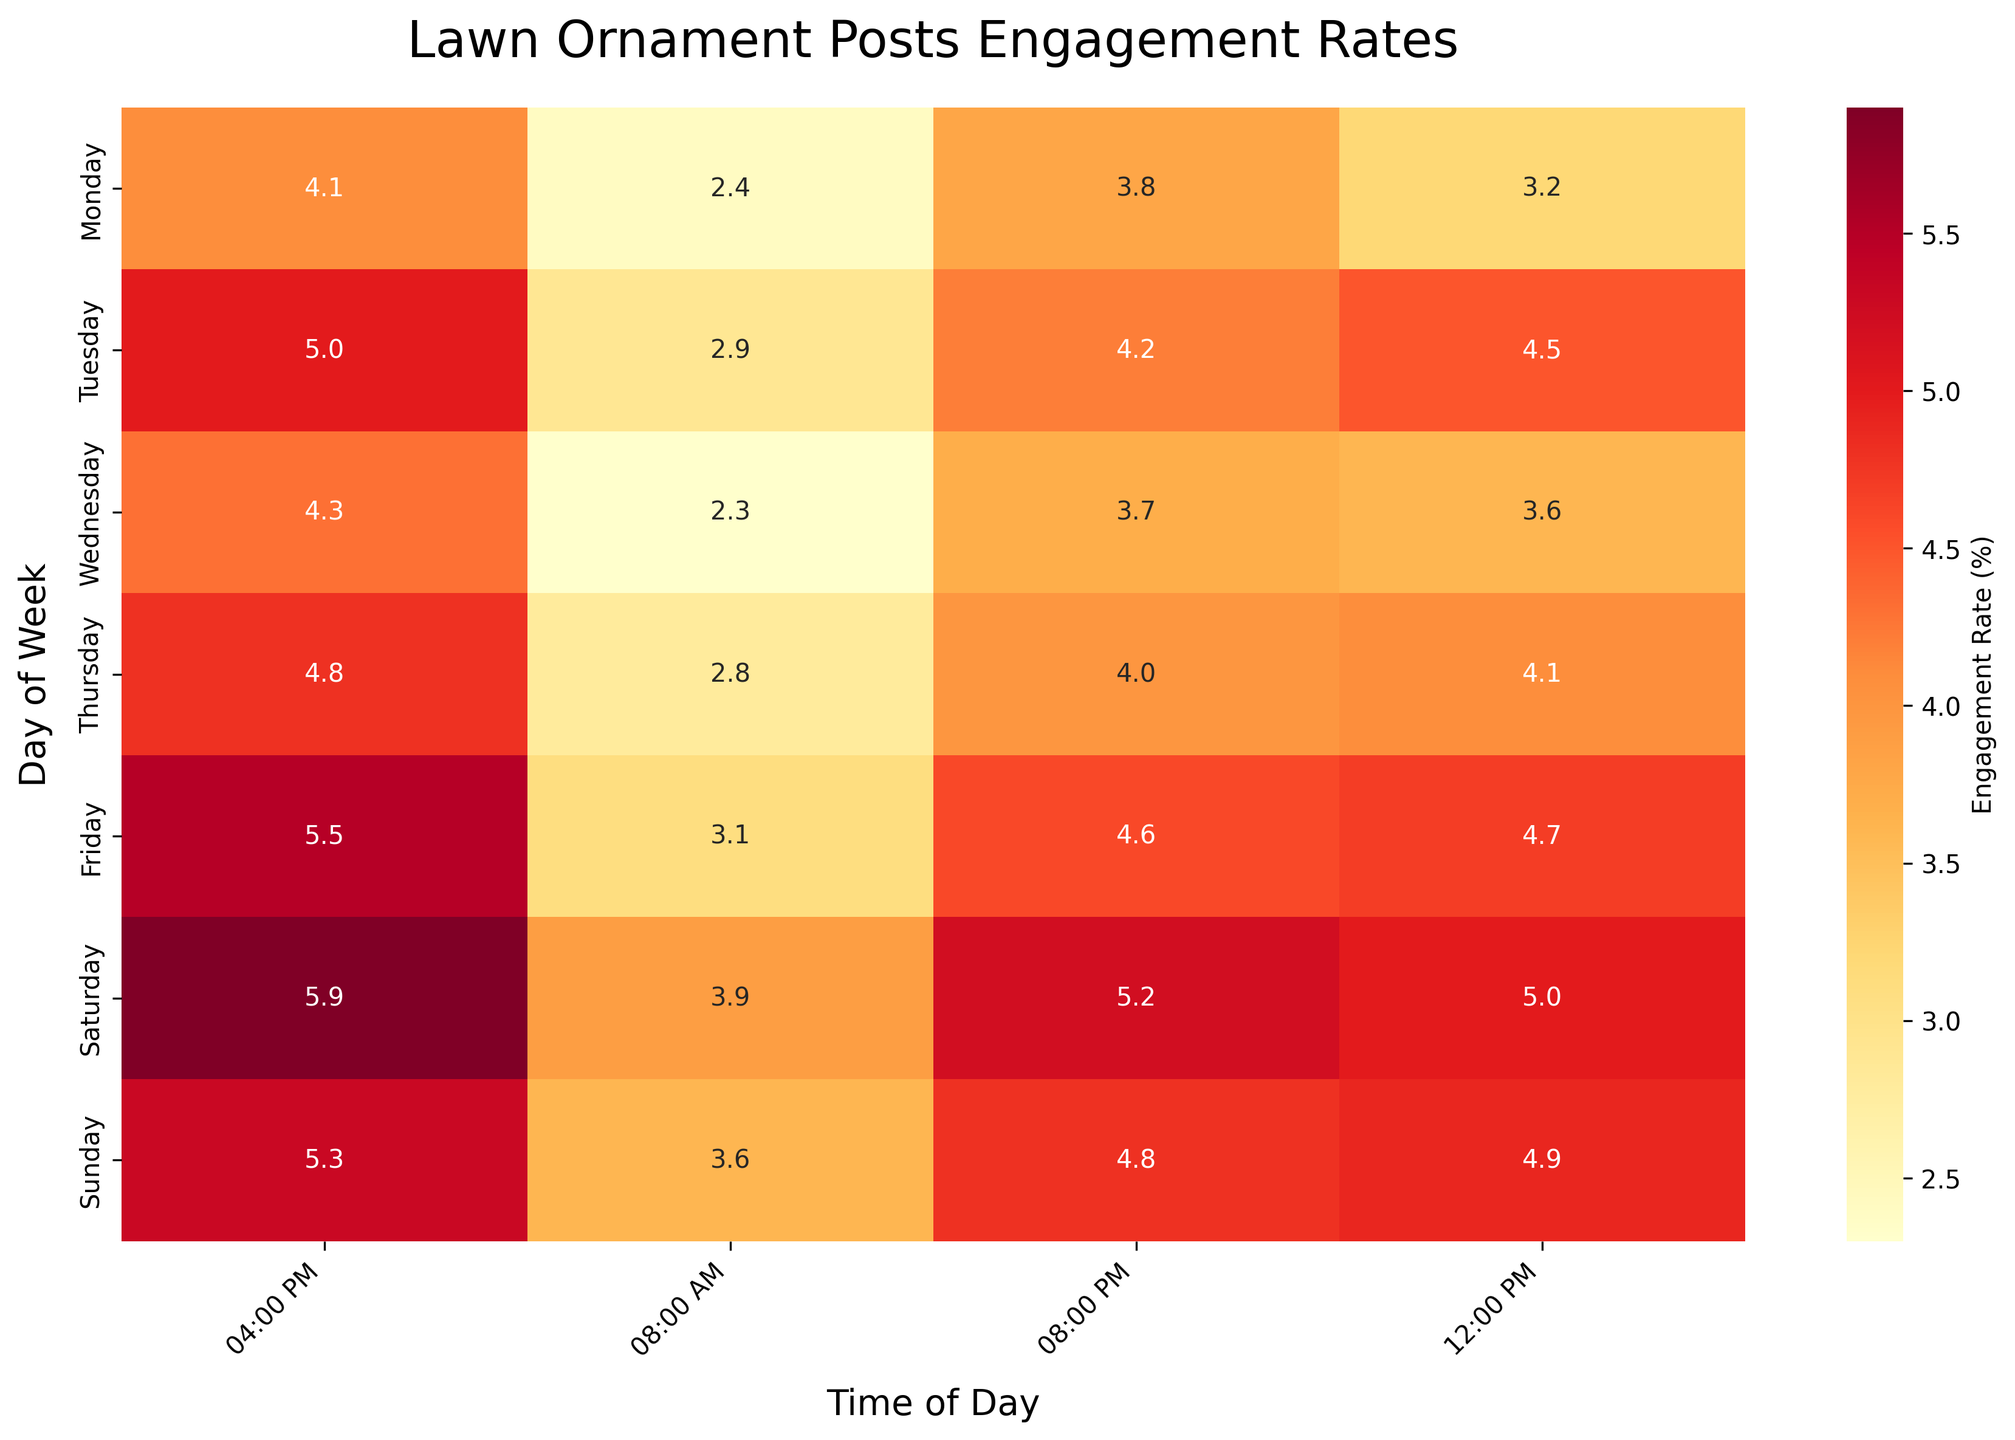Which day has the highest engagement rate at 8:00 PM? Look at the heatmap on the row corresponding to 08:00 PM. The darkest cell in this column corresponds to Saturday with 5.2%.
Answer: Saturday What's the average engagement rate at 12:00 PM across all days? Add up the engagement rates at 12:00 PM for each day: 3.2 + 4.5 + 3.6 + 4.1 + 4.7 + 5.0 + 4.9 and then divide by 7 (number of days). The calculation is (3.2 + 4.5 + 3.6 + 4.1 + 4.7 + 5.0 + 4.9) / 7 = 30.0 / 7 ≈ 4.29%.
Answer: 4.29% Which time slot shows the highest engagement rate on Friday? Look at the heatmap along the row for Friday and find the highest value. The highest engagement rate for Friday is 5.5% at 04:00 PM.
Answer: 04:00 PM How much higher is the engagement rate on Saturday at 04:00 PM compared to 08:00 AM? Subtract the engagement rate at 08:00 AM from the engagement rate at 04:00 PM for Saturday: 5.9% - 3.9% = 2.0%.
Answer: 2.0% Which day has the lowest engagement rate at 08:00 AM? Look at the heatmap on the row corresponding to 08:00 AM. The lightest cell in this column corresponds to Wednesday with 2.3%.
Answer: Wednesday Is there a general time of day when engagement rates are higher across all days? Compare the engagement rates in each column corresponding to specific times. Engaging hours like 04:00 PM generally have higher rates, evidenced by darker cells in this time slot across multiple days.
Answer: 04:00 PM What’s the difference between the highest and lowest engagement rates across all the days and times? Identify the highest rate (5.9% on Saturday at 04:00 PM) and the lowest rate (2.3% on Wednesday at 08:00 AM). Subtract the lowest from the highest: 5.9% - 2.3% = 3.6%.
Answer: 3.6% On which day is the engagement rate consistently above 4% after 12:00 PM? Scan the rows after 12:00 PM and find the one with all values above 4%. Saturday's engagement rates are consistently above 4% after 12:00 PM (5.0%, 5.9%, 5.2%).
Answer: Saturday 